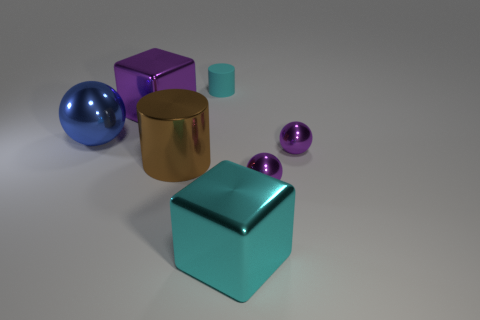There is a purple object that is in front of the big blue metallic sphere and behind the metal cylinder; what material is it?
Keep it short and to the point. Metal. There is a cyan thing that is behind the large purple metal thing; does it have the same shape as the big object that is on the left side of the big purple metal cube?
Offer a terse response. No. There is a metal thing that is the same color as the small matte cylinder; what is its shape?
Ensure brevity in your answer.  Cube. What number of objects are either rubber things that are behind the brown cylinder or big brown shiny cylinders?
Your answer should be very brief. 2. Is the brown metallic cylinder the same size as the blue thing?
Provide a short and direct response. Yes. What is the color of the ball that is in front of the large brown metallic thing?
Your answer should be compact. Purple. The blue sphere that is the same material as the big cylinder is what size?
Provide a short and direct response. Large. Does the rubber thing have the same size as the block to the right of the cyan rubber cylinder?
Provide a succinct answer. No. There is a cube on the right side of the big purple cube; what material is it?
Give a very brief answer. Metal. There is a large object behind the large metal sphere; what number of metallic cubes are behind it?
Offer a terse response. 0. 